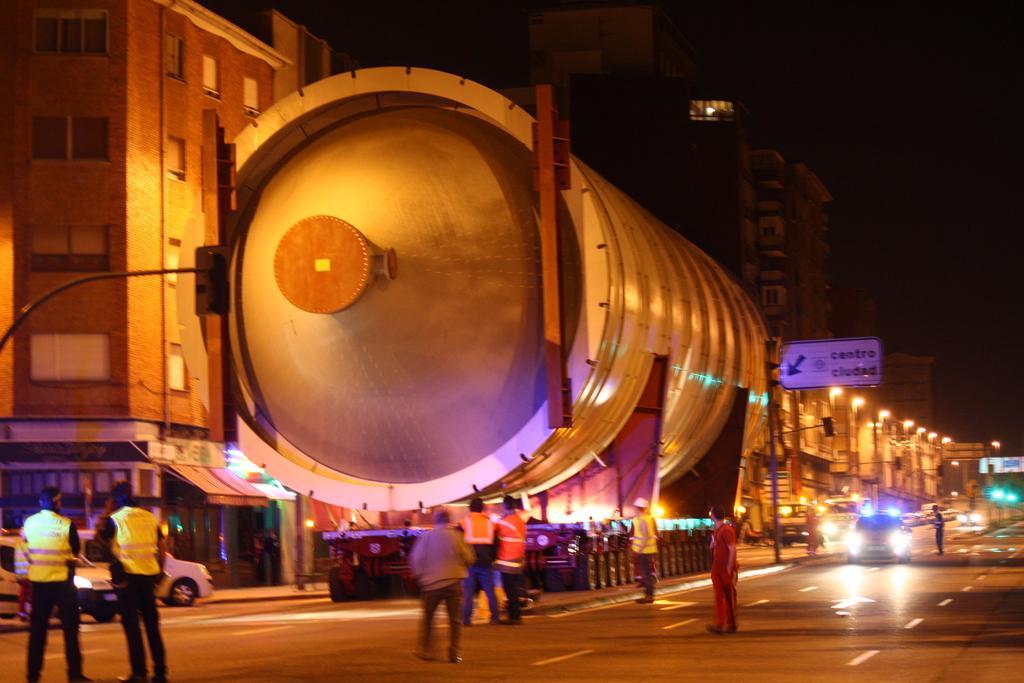Could you give a brief overview of what you see in this image? In this image we can see many buildings, in front there is a cylindrical architecture on a truck, there are group of persons standing on a road, there are cars travelling on a road, there is a white board, there is a pole, there are lights. 